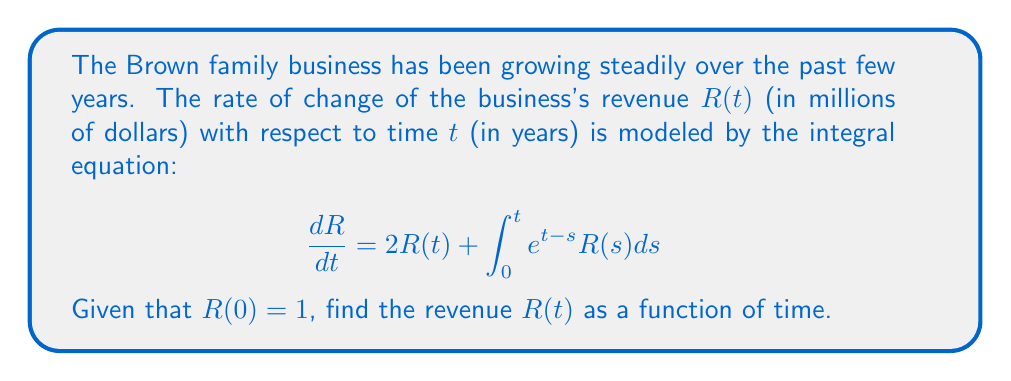Help me with this question. To solve this integral equation, we'll use the Laplace transform method:

1) Take the Laplace transform of both sides of the equation:
   $$\mathcal{L}\{\frac{dR}{dt}\} = \mathcal{L}\{2R(t)\} + \mathcal{L}\{\int_0^t e^{t-s}R(s)ds\}$$

2) Using Laplace transform properties:
   $$sR(s) - R(0) = 2R(s) + R(s)\mathcal{L}\{e^t\}$$
   $$sR(s) - 1 = 2R(s) + \frac{R(s)}{s-1}$$

3) Simplify:
   $$sR(s) - 1 = 2R(s) + \frac{R(s)}{s-1}$$
   $$(s-2)R(s) - \frac{R(s)}{s-1} = 1$$
   $$\frac{(s-2)(s-1)R(s) - R(s)}{s-1} = 1$$
   $$\frac{(s^2-3s+2)R(s)}{s-1} = 1$$

4) Solve for R(s):
   $$R(s) = \frac{s-1}{s^2-3s+2} = \frac{s-1}{(s-1)(s-2)} = \frac{1}{s-2}$$

5) Take the inverse Laplace transform:
   $$R(t) = \mathcal{L}^{-1}\{\frac{1}{s-2}\} = e^{2t}$$

Therefore, the revenue function R(t) is an exponential growth function.
Answer: $R(t) = e^{2t}$ 